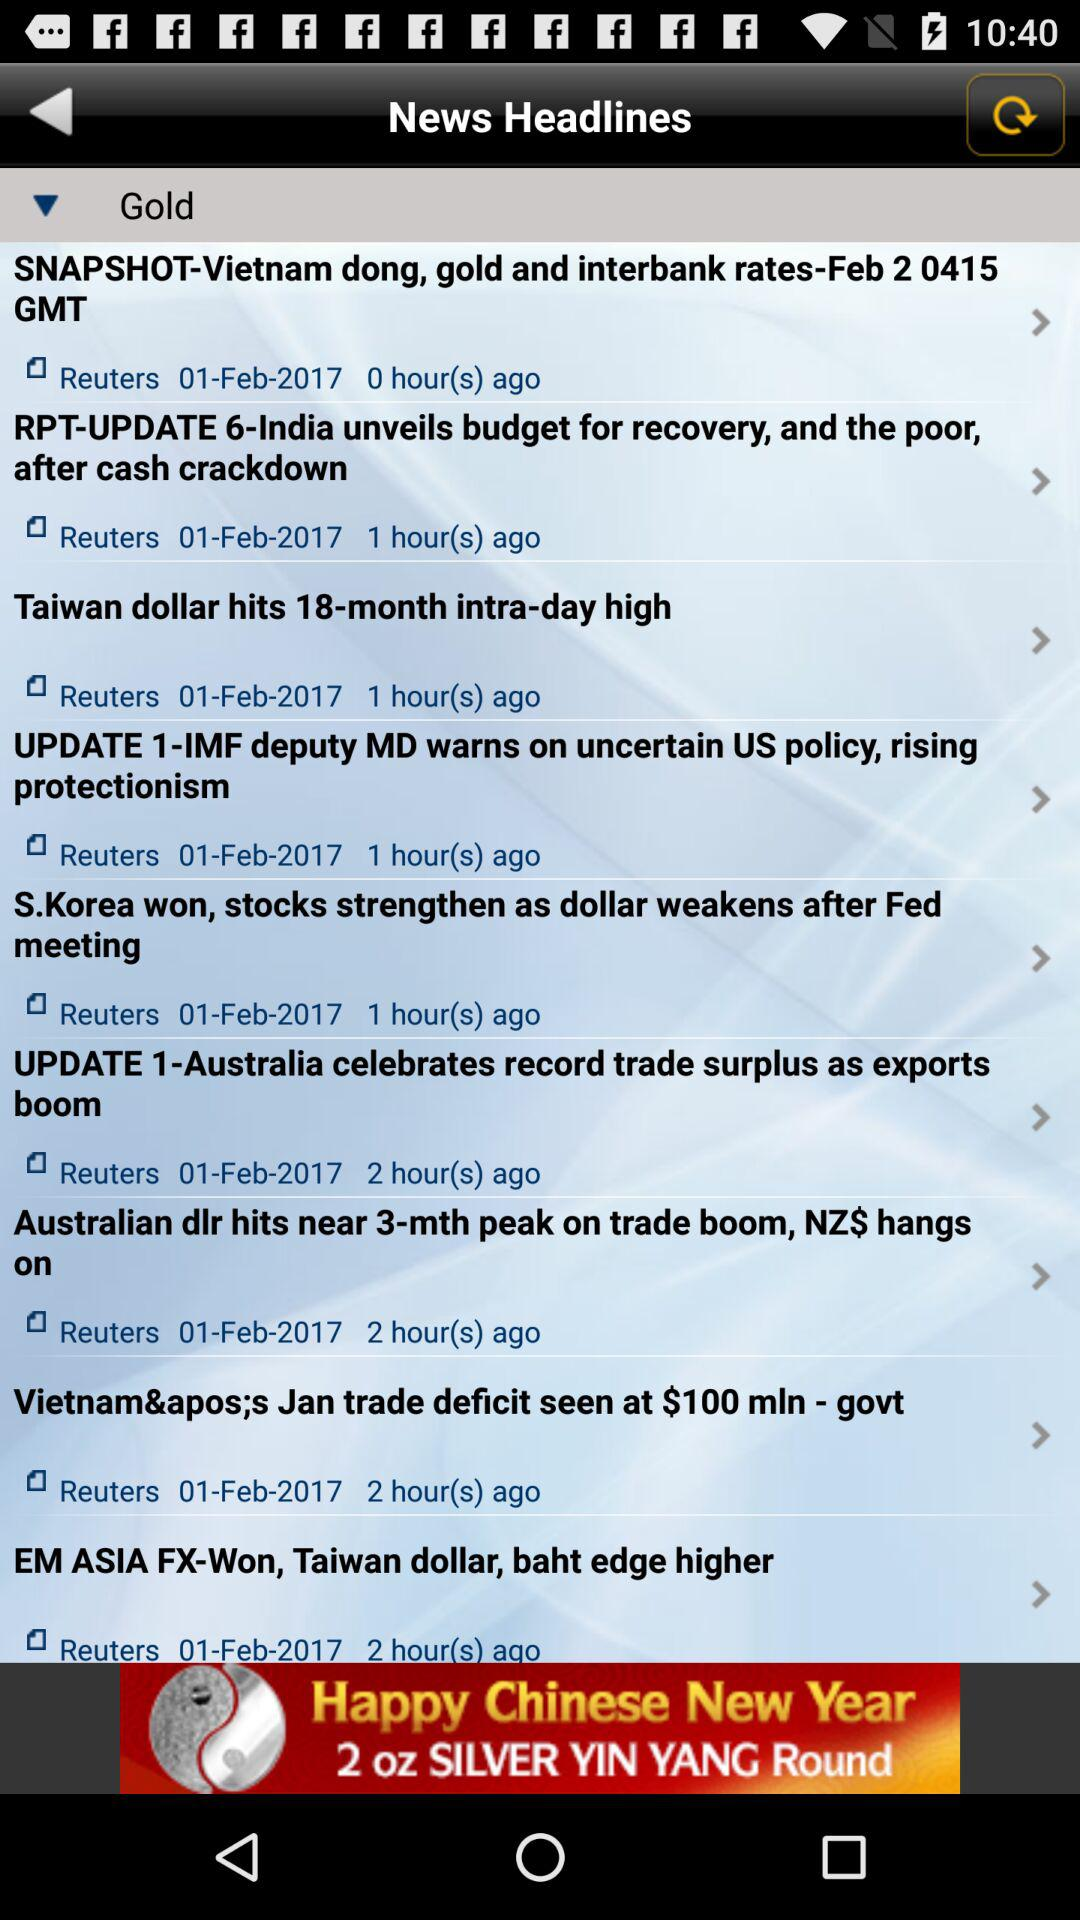When did the "Taiwan dollar hits 18-month intra-day high"? Taiwan's dollar hit an 18-month intra-day high on February 01, 2017. 